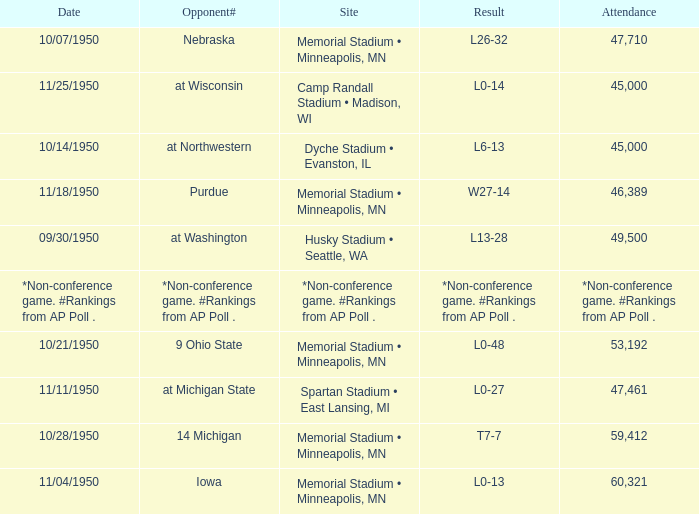What is the Date when the result is *non-conference game. #rankings from ap poll .? *Non-conference game. #Rankings from AP Poll . Would you be able to parse every entry in this table? {'header': ['Date', 'Opponent#', 'Site', 'Result', 'Attendance'], 'rows': [['10/07/1950', 'Nebraska', 'Memorial Stadium • Minneapolis, MN', 'L26-32', '47,710'], ['11/25/1950', 'at Wisconsin', 'Camp Randall Stadium • Madison, WI', 'L0-14', '45,000'], ['10/14/1950', 'at Northwestern', 'Dyche Stadium • Evanston, IL', 'L6-13', '45,000'], ['11/18/1950', 'Purdue', 'Memorial Stadium • Minneapolis, MN', 'W27-14', '46,389'], ['09/30/1950', 'at Washington', 'Husky Stadium • Seattle, WA', 'L13-28', '49,500'], ['*Non-conference game. #Rankings from AP Poll .', '*Non-conference game. #Rankings from AP Poll .', '*Non-conference game. #Rankings from AP Poll .', '*Non-conference game. #Rankings from AP Poll .', '*Non-conference game. #Rankings from AP Poll .'], ['10/21/1950', '9 Ohio State', 'Memorial Stadium • Minneapolis, MN', 'L0-48', '53,192'], ['11/11/1950', 'at Michigan State', 'Spartan Stadium • East Lansing, MI', 'L0-27', '47,461'], ['10/28/1950', '14 Michigan', 'Memorial Stadium • Minneapolis, MN', 'T7-7', '59,412'], ['11/04/1950', 'Iowa', 'Memorial Stadium • Minneapolis, MN', 'L0-13', '60,321']]} 